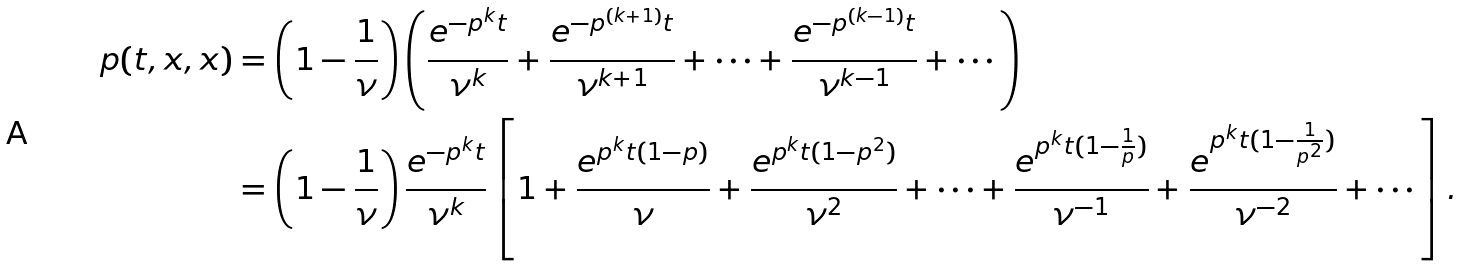Convert formula to latex. <formula><loc_0><loc_0><loc_500><loc_500>p ( t , x , x ) & = \left ( 1 - \frac { 1 } { \nu } \right ) \left ( \frac { e ^ { - p ^ { k } t } } { \nu ^ { k } } + \frac { e ^ { - p ^ { ( k + 1 ) } t } } { \nu ^ { k + 1 } } + \cdots + \frac { e ^ { - p ^ { ( k - 1 ) } t } } { \nu ^ { k - 1 } } + \cdots \right ) \\ & = \left ( 1 - \frac { 1 } { \nu } \right ) \frac { e ^ { - p ^ { k } t } } { \nu ^ { k } } \left [ 1 + \frac { e ^ { p ^ { k } t ( 1 - p ) } } { \nu } + \frac { e ^ { p ^ { k } t ( 1 - p ^ { 2 } ) } } { \nu ^ { 2 } } + \cdots + \frac { e ^ { p ^ { k } t ( 1 - \frac { 1 } { p } ) } } { \nu ^ { - 1 } } + \frac { e ^ { p ^ { k } t ( 1 - \frac { 1 } { p ^ { 2 } } ) } } { \nu ^ { - 2 } } + \cdots \right ] . \\</formula> 